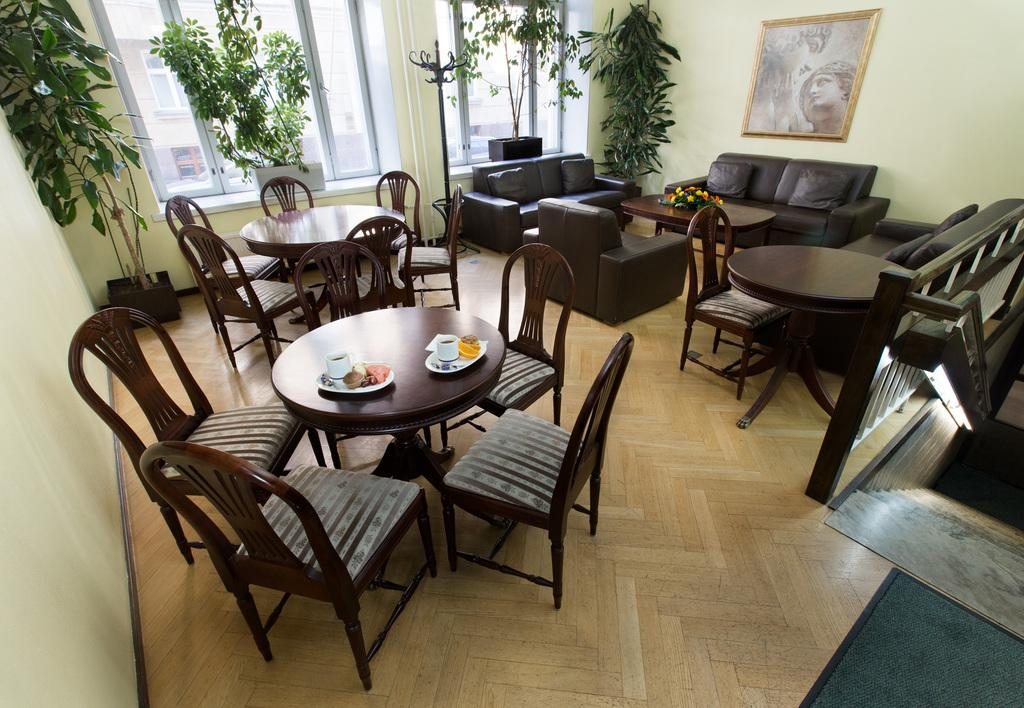What type of furniture can be seen in the image? There are different tables and couches in the image. What other objects are present in the image? There are plants, windows, and a painting attached to the wall in the image. What songs can be heard playing in the background of the image? There is no audio or indication of music in the image, so it's not possible to determine what songs might be heard. 